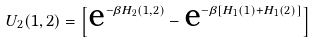<formula> <loc_0><loc_0><loc_500><loc_500>U _ { 2 } ( 1 , 2 ) = \left [ \text {e} ^ { - \beta H _ { 2 } ( 1 , 2 ) } - \text {e} ^ { - \beta \left [ H _ { 1 } ( 1 ) + H _ { 1 } ( 2 ) \right ] } \right ]</formula> 